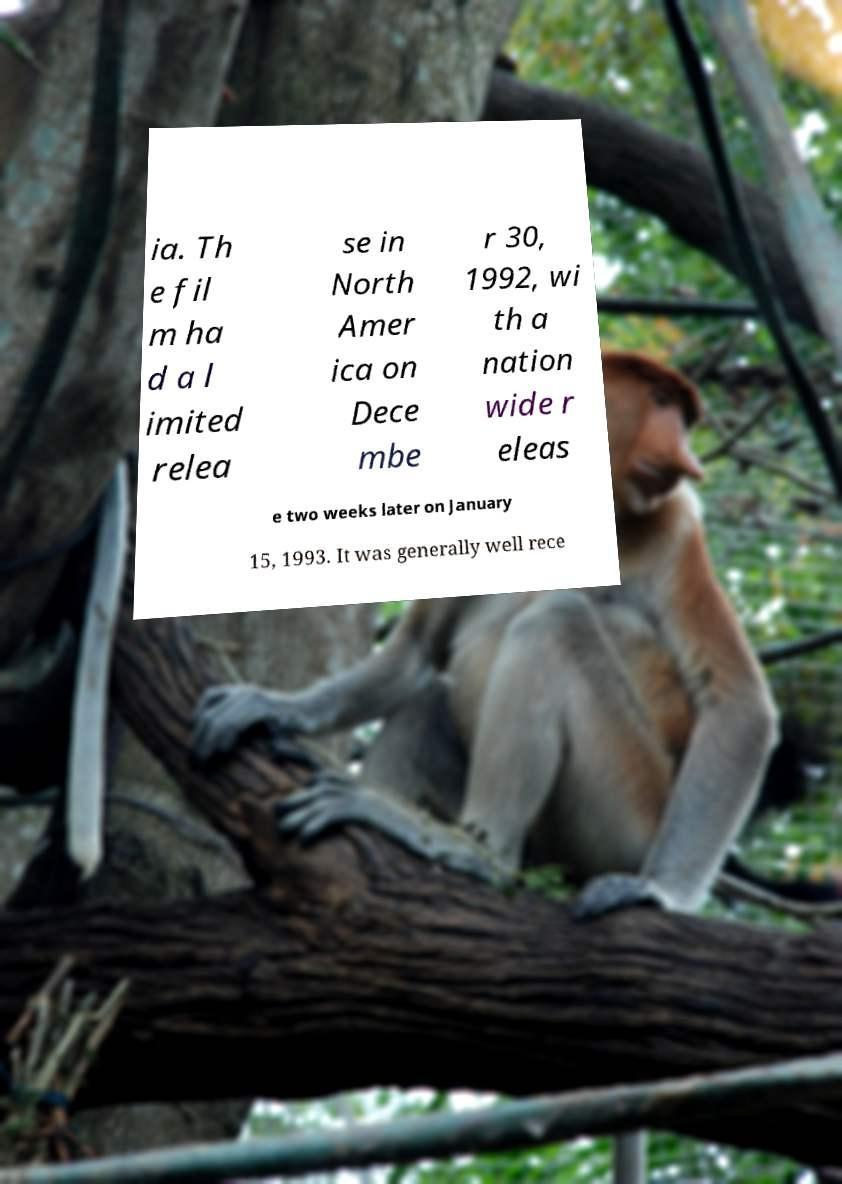There's text embedded in this image that I need extracted. Can you transcribe it verbatim? ia. Th e fil m ha d a l imited relea se in North Amer ica on Dece mbe r 30, 1992, wi th a nation wide r eleas e two weeks later on January 15, 1993. It was generally well rece 